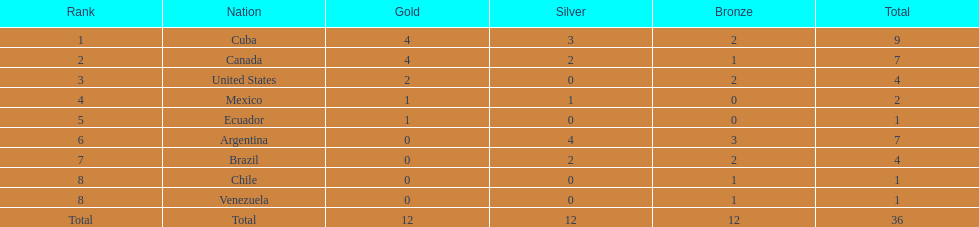What is the total number of nations that did not win gold? 4. 